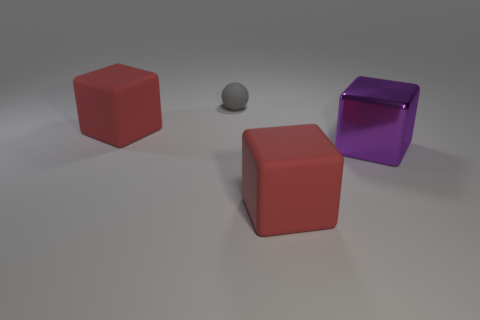Subtract all big matte cubes. How many cubes are left? 1 Add 4 red things. How many objects exist? 8 Subtract all green cylinders. How many red blocks are left? 2 Subtract all red blocks. How many blocks are left? 1 Subtract all spheres. How many objects are left? 3 Add 1 balls. How many balls are left? 2 Add 3 tiny things. How many tiny things exist? 4 Subtract 0 blue spheres. How many objects are left? 4 Subtract 2 blocks. How many blocks are left? 1 Subtract all green spheres. Subtract all green cylinders. How many spheres are left? 1 